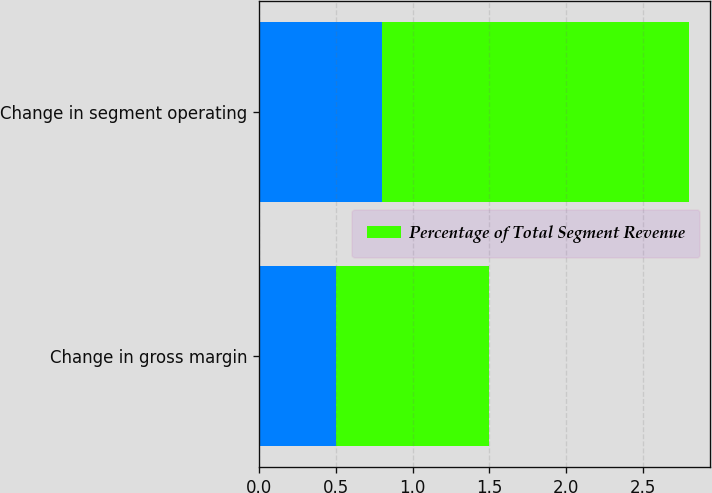Convert chart to OTSL. <chart><loc_0><loc_0><loc_500><loc_500><stacked_bar_chart><ecel><fcel>Change in gross margin<fcel>Change in segment operating<nl><fcel>nan<fcel>0.5<fcel>0.8<nl><fcel>Percentage of Total Segment Revenue<fcel>1<fcel>2<nl></chart> 